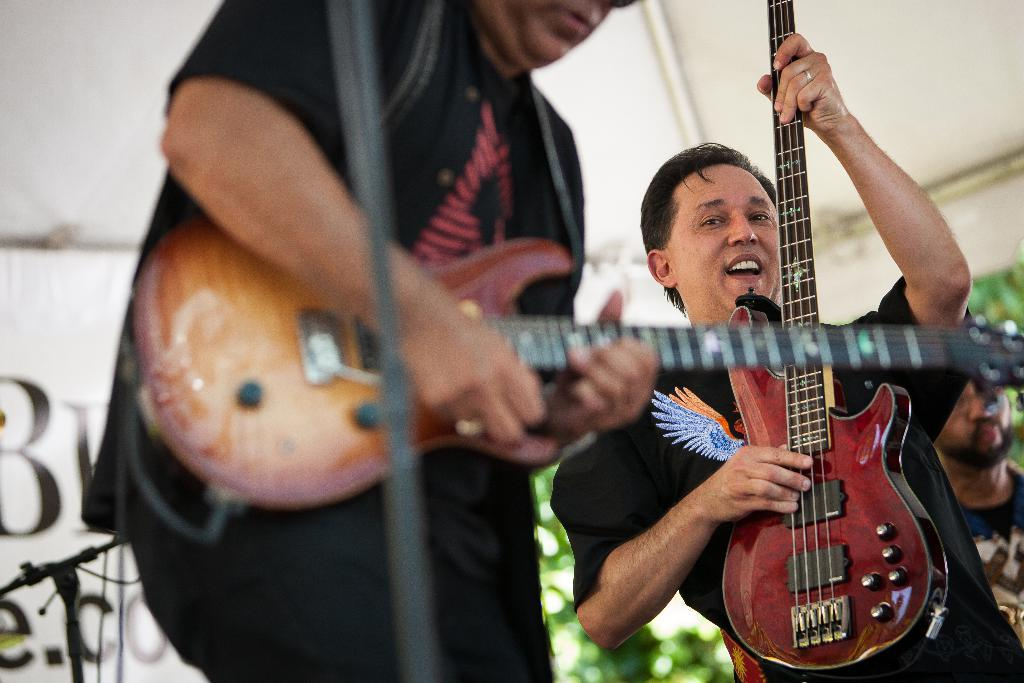How many people are in the image? There are people in the image, but the exact number is not specified. What are the people doing in the image? The people are standing and holding music instruments. What color are the music instruments? The music instruments are brown in color. What are the people doing with the microphone? The people are singing into a microphone. What type of scarecrow is standing next to the people in the image? There is no scarecrow present in the image. What thoughts are going through the people's minds while they are singing? The thoughts of the people cannot be determined from the image alone. 